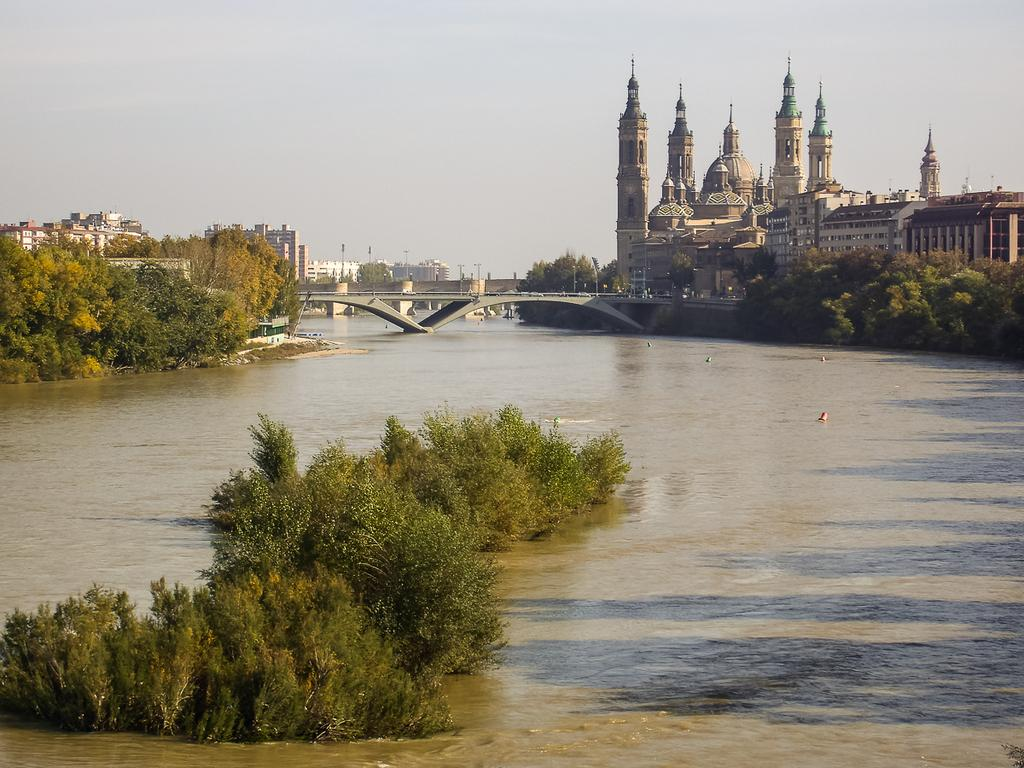What type of vegetation can be seen in the image? There are trees in the image. What is the color of the trees? The trees are green. What can be seen in the background of the image? There is water, a bridge, and buildings in the background. What colors are the buildings? The buildings have white, cream, and brown colors. What other objects are present in the image? There are poles in the image. What is the color of the sky in the image? The sky is white in color. What type of toys can be seen in the image? There are no toys present in the image. 